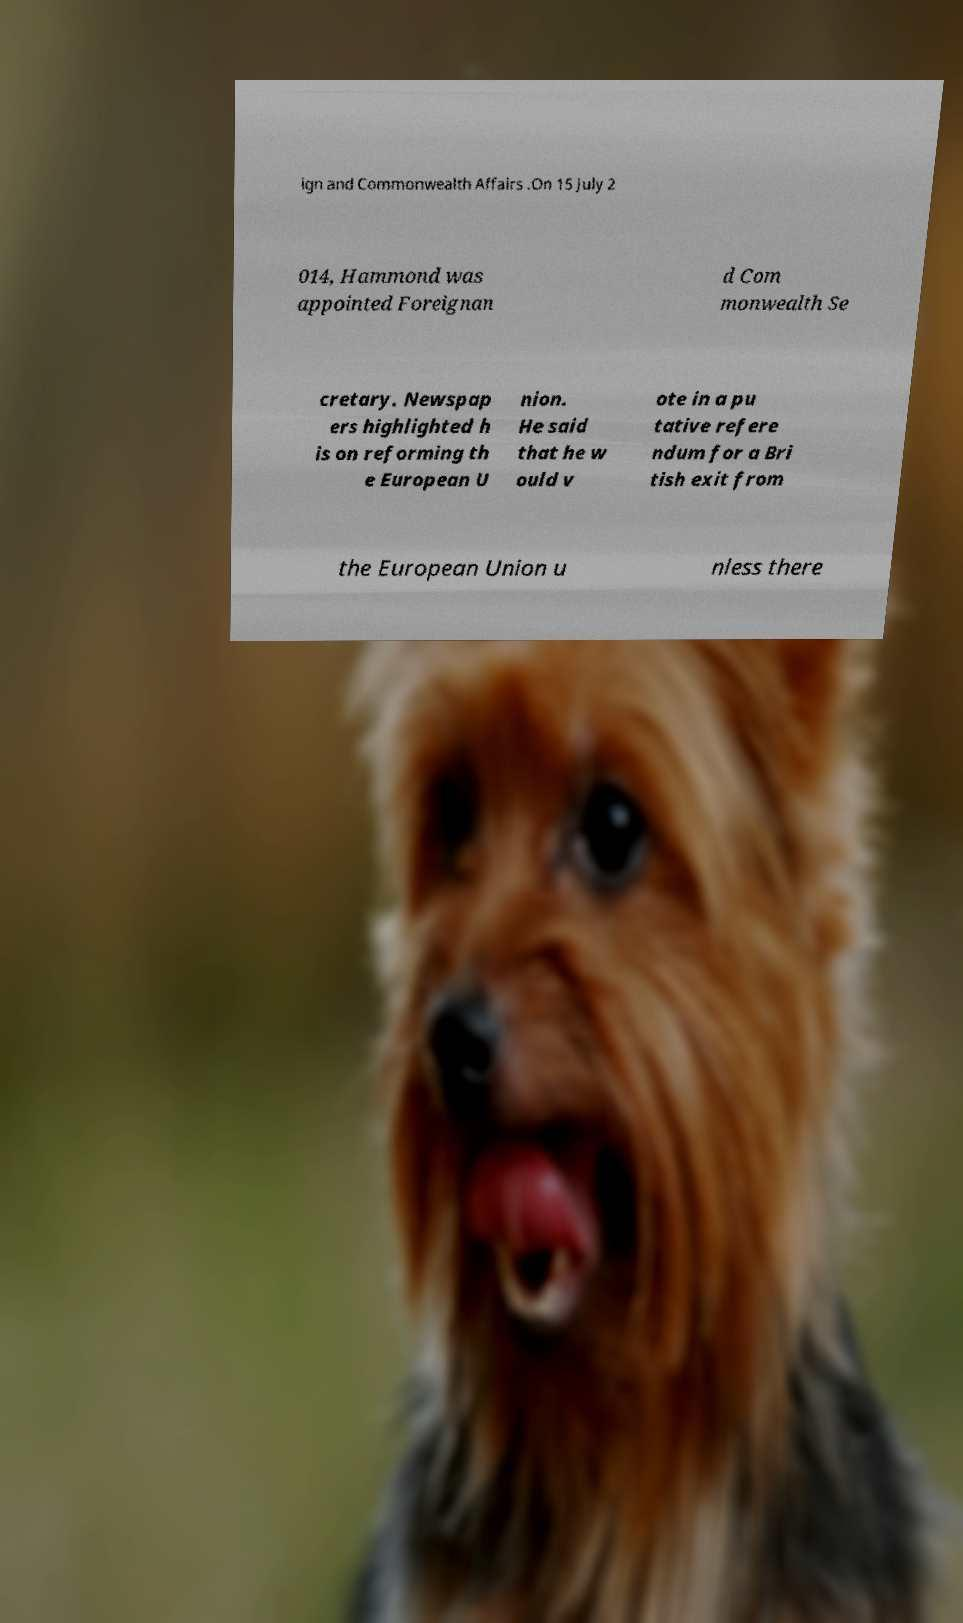Could you extract and type out the text from this image? ign and Commonwealth Affairs .On 15 July 2 014, Hammond was appointed Foreignan d Com monwealth Se cretary. Newspap ers highlighted h is on reforming th e European U nion. He said that he w ould v ote in a pu tative refere ndum for a Bri tish exit from the European Union u nless there 